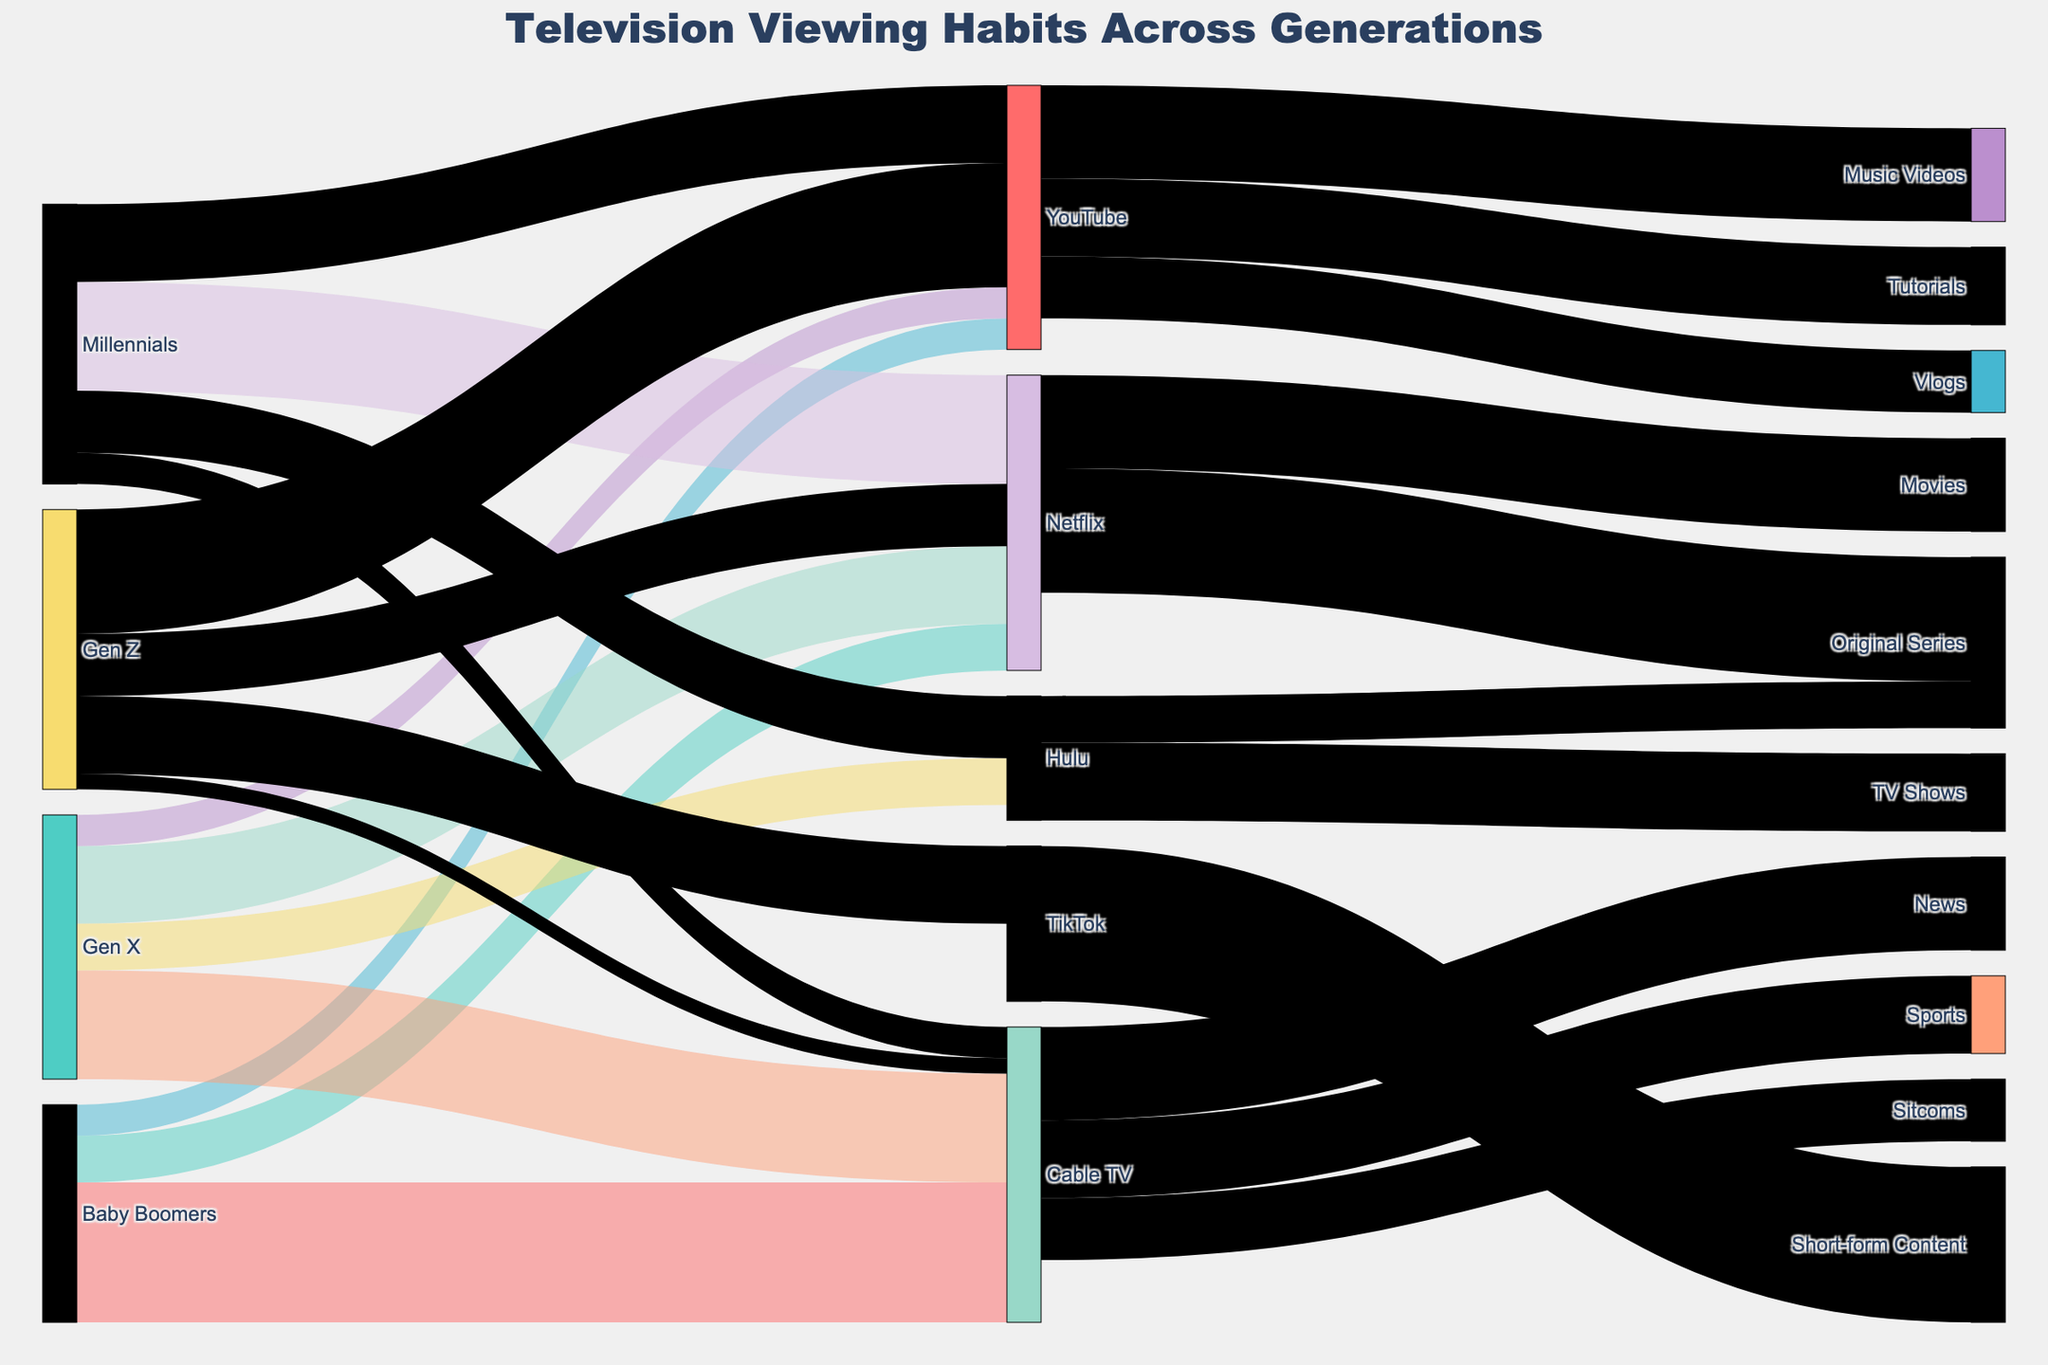How many age groups are represented in the figure? The figure depicts four distinct age groups, which are Baby Boomers, Gen X, Millennials, and Gen Z. This can be observed by looking at the labels in the figure.
Answer: 4 Which age group has the highest viewership for YouTube? By following the lines leading to YouTube, it's clear that Gen Z has the highest viewership, with a value of 40.
Answer: Gen Z What is the total viewership for Netflix across all age groups? Summing up the viewership values for Netflix from each age group: Baby Boomers (15) + Gen X (25) + Millennials (35) + Gen Z (20) results in a total of 15 + 25 + 35 + 20 = 95.
Answer: 95 How much more do Baby Boomers watch Cable TV compared to Millennials? From the diagram, Baby Boomers watch Cable TV 45 units and Millennials watch 10 units. The difference is 45 - 10 = 35.
Answer: 35 Between Gen X and Millennials, which group watches Hulu more, and by how much? Gen X watches Hulu with a value of 15, while Millennials watch Hulu with a value of 20. The difference is 20 - 15 = 5. Millennials watch Hulu 5 units more than Gen X.
Answer: Millennials, by 5 Which content category has the highest viewership within Cable TV? The Cable TV node is connected to News, Sports, and Sitcoms with viewership values of 30, 25, and 20, respectively. News has the highest value of 30.
Answer: News What is the combined viewership for Original Series from Netflix and Hulu? Adding the viewership values for Original Series from both Netflix (40) and Hulu (15) gives 40 + 15 = 55.
Answer: 55 Which age group watches the least amount of Cable TV? By looking at the figures for Cable TV, Gen Z has the least viewership at a value of 5.
Answer: Gen Z In terms of TikTok usage, which age group is highlighted and what is the value? The figure indicates that Gen Z is the age group for TikTok with a viewership value of 25.
Answer: Gen Z, 25 What are the main content types viewed on YouTube, and which is the most popular? The main content types viewed on YouTube are Music Videos, Tutorials, and Vlogs with respective values of 30, 25, and 20. Music Videos are the most popular with a value of 30.
Answer: Music Videos 